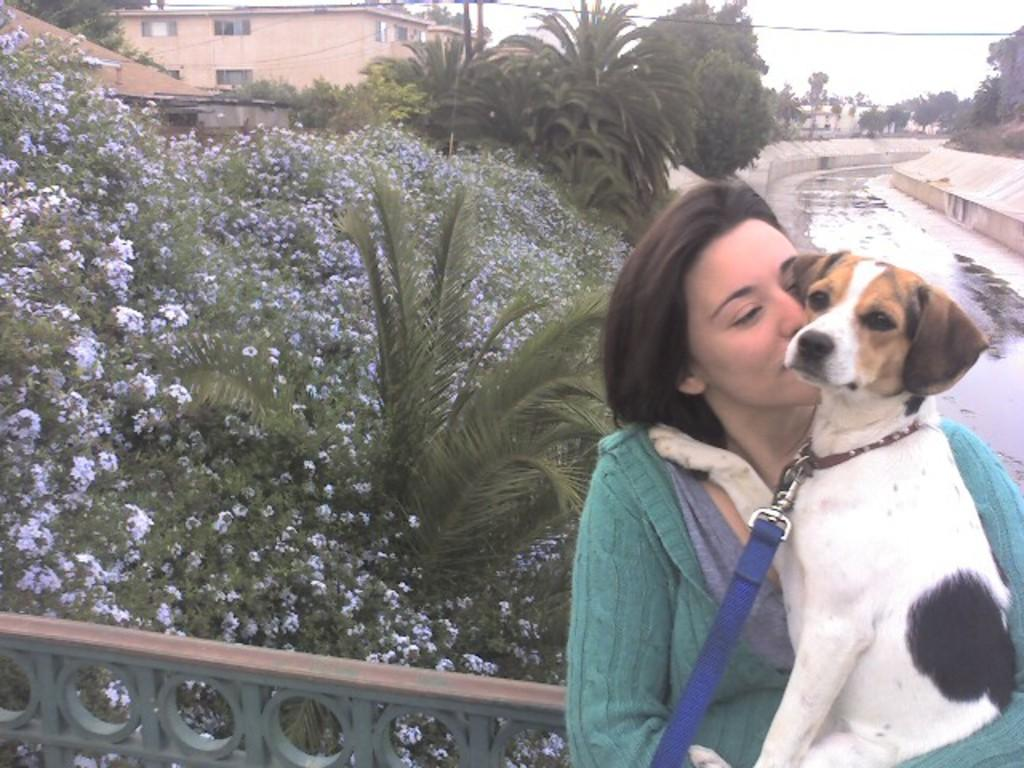Who is present in the image? There is a woman in the image. What is the woman wearing? The woman is wearing a blue dress. How is the woman's hair styled? The woman's hair is short. What is the woman holding in the image? The woman is holding a dog. What type of plastic material can be seen in the image? There is no plastic material present in the image. What kind of marble structure is visible in the background of the image? There is no marble structure visible in the image. 